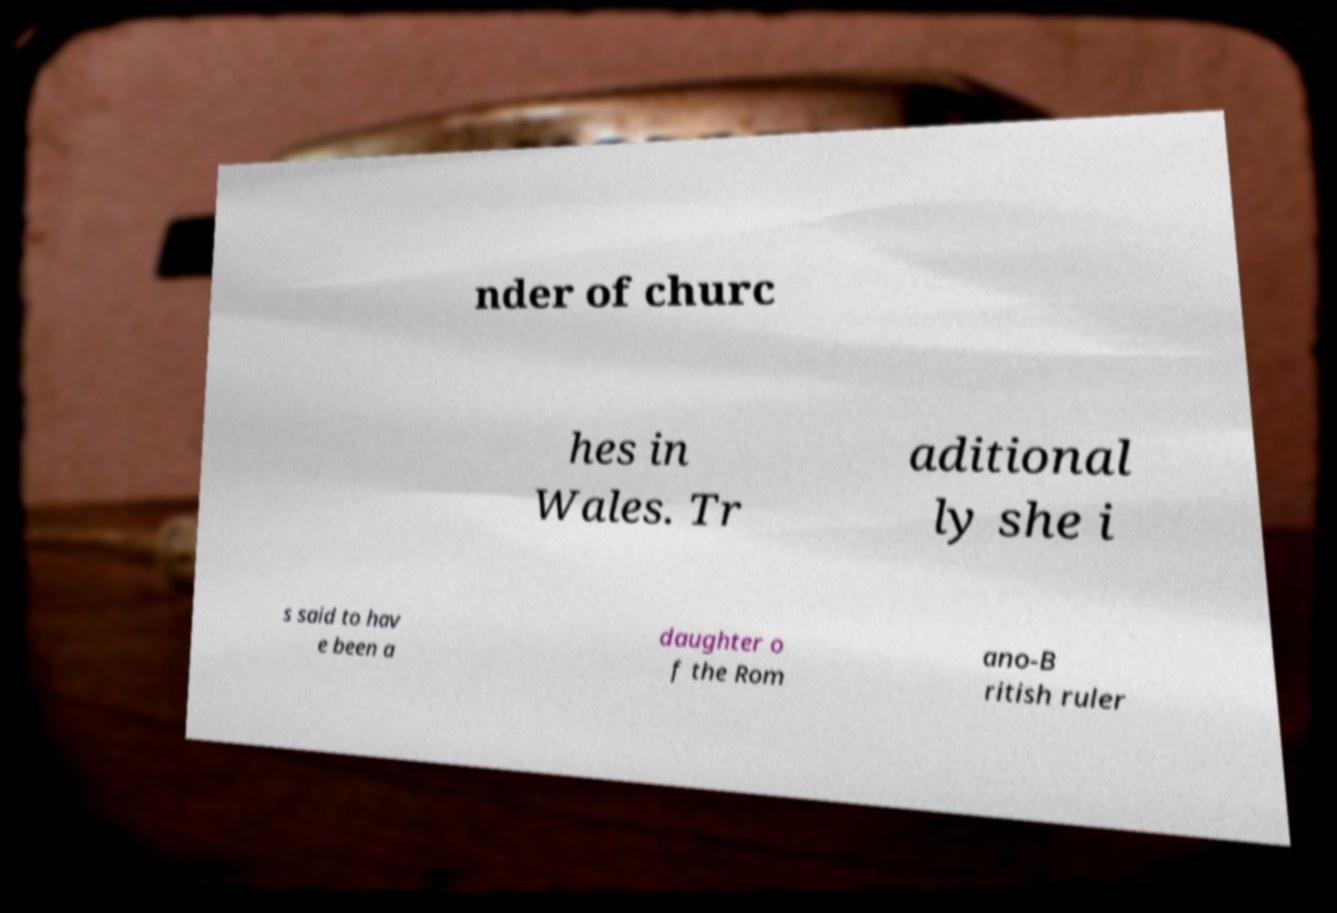Could you extract and type out the text from this image? nder of churc hes in Wales. Tr aditional ly she i s said to hav e been a daughter o f the Rom ano-B ritish ruler 